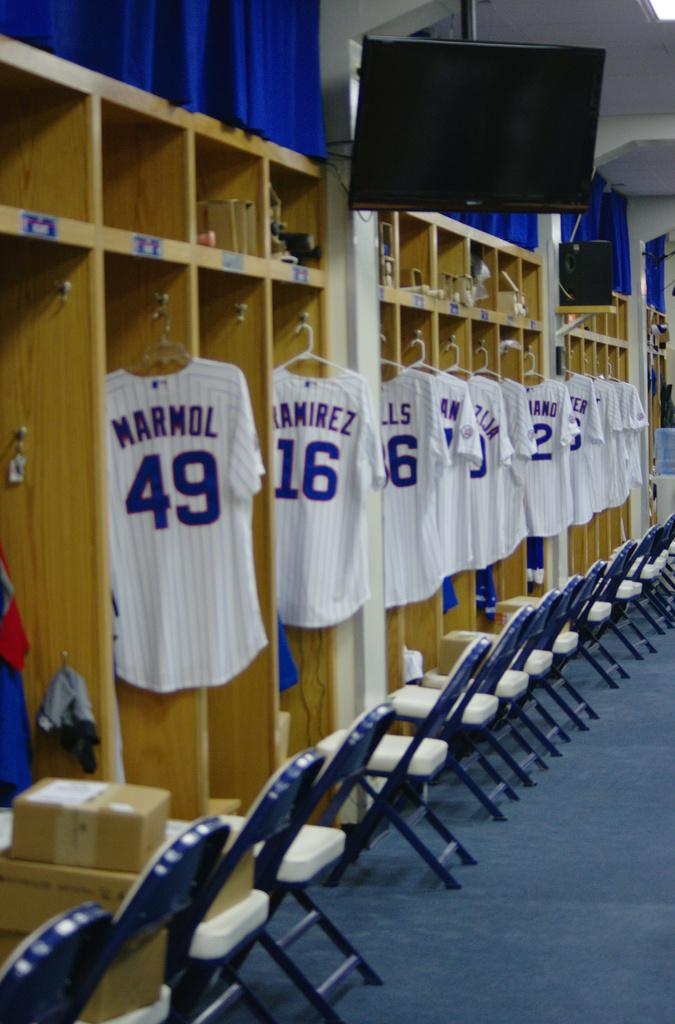<image>
Summarize the visual content of the image. Out of the jerseys lined up in a locker room, Marmol's appears first. 